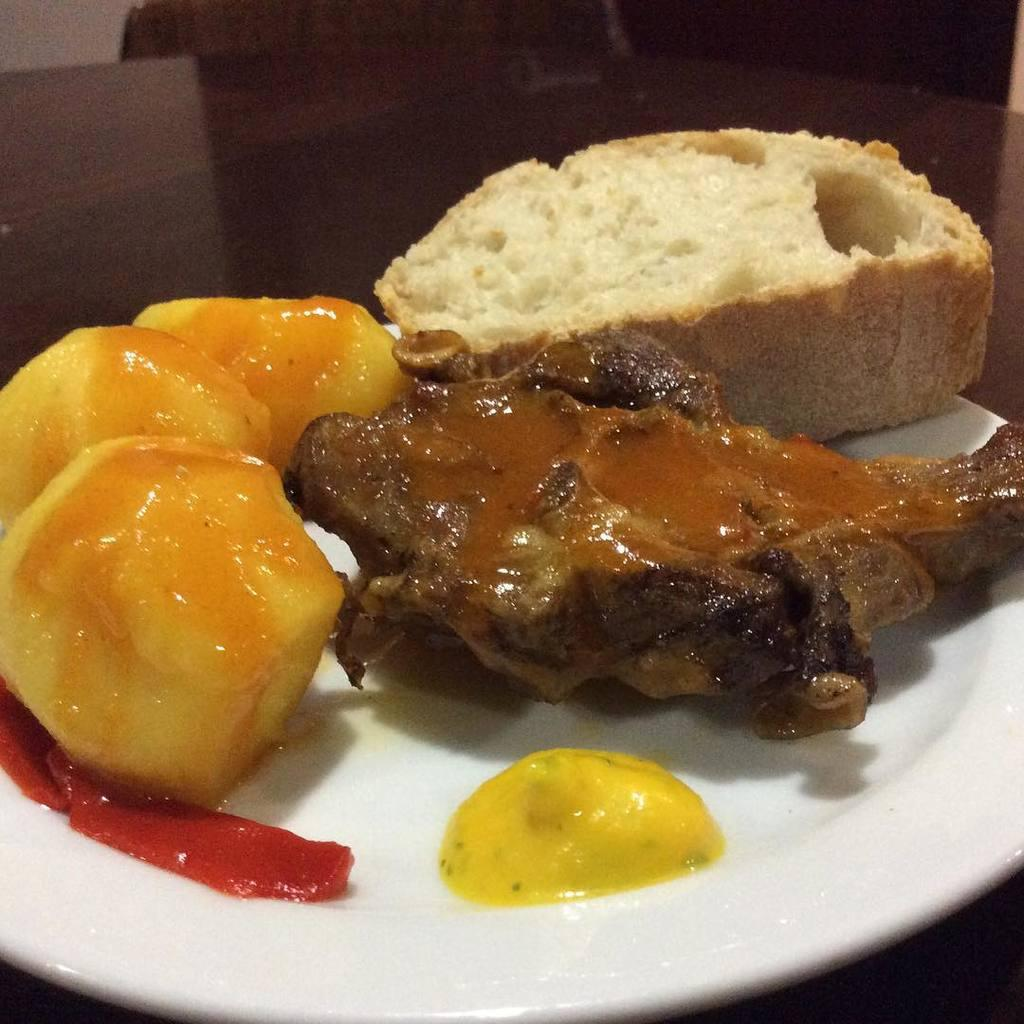What is present on the plate in the image? There is a food item on the plate in the image. Can you describe the plate in the image? The plate is the main object in the image, and it is holding the food item. What type of leather material is used to make the lamp in the image? There is no lamp present in the image, so it is not possible to determine the type of leather material used. 